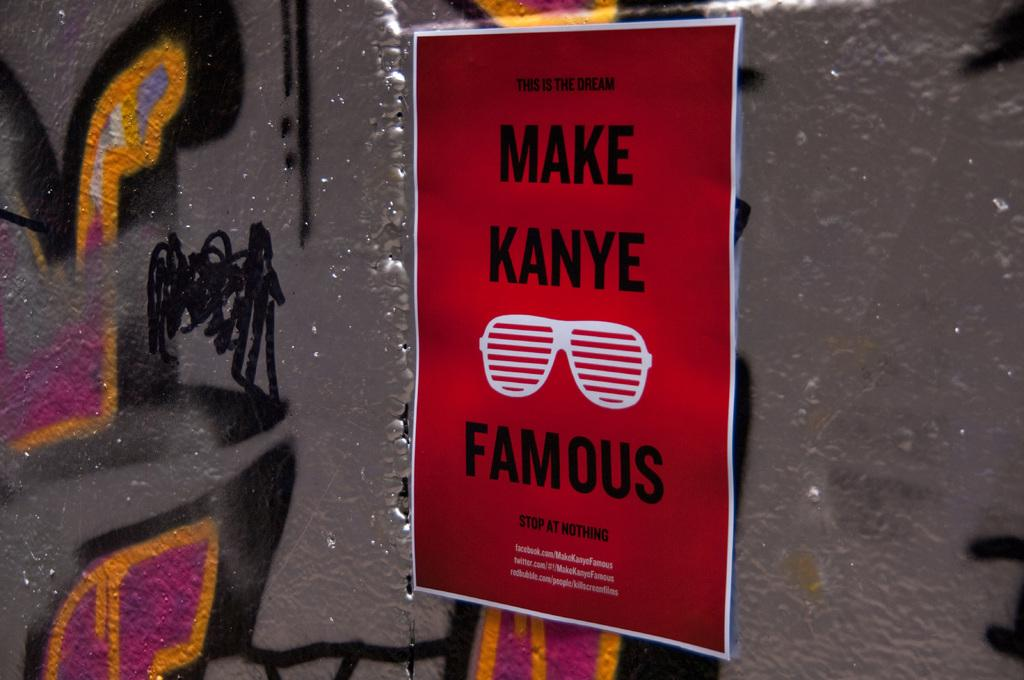What is the main subject of the image? The main subject of the image is a poster. What can be found on the poster? The poster contains text and has goggles depicted on it. Can you describe the grey object in the image? There is a grey object in the image that resembles an iron wall. What year is depicted on the poster? There is no year depicted on the poster; it only contains text and goggles. How many losses are shown on the poster? There are no losses depicted on the poster; it only contains text and goggles. 